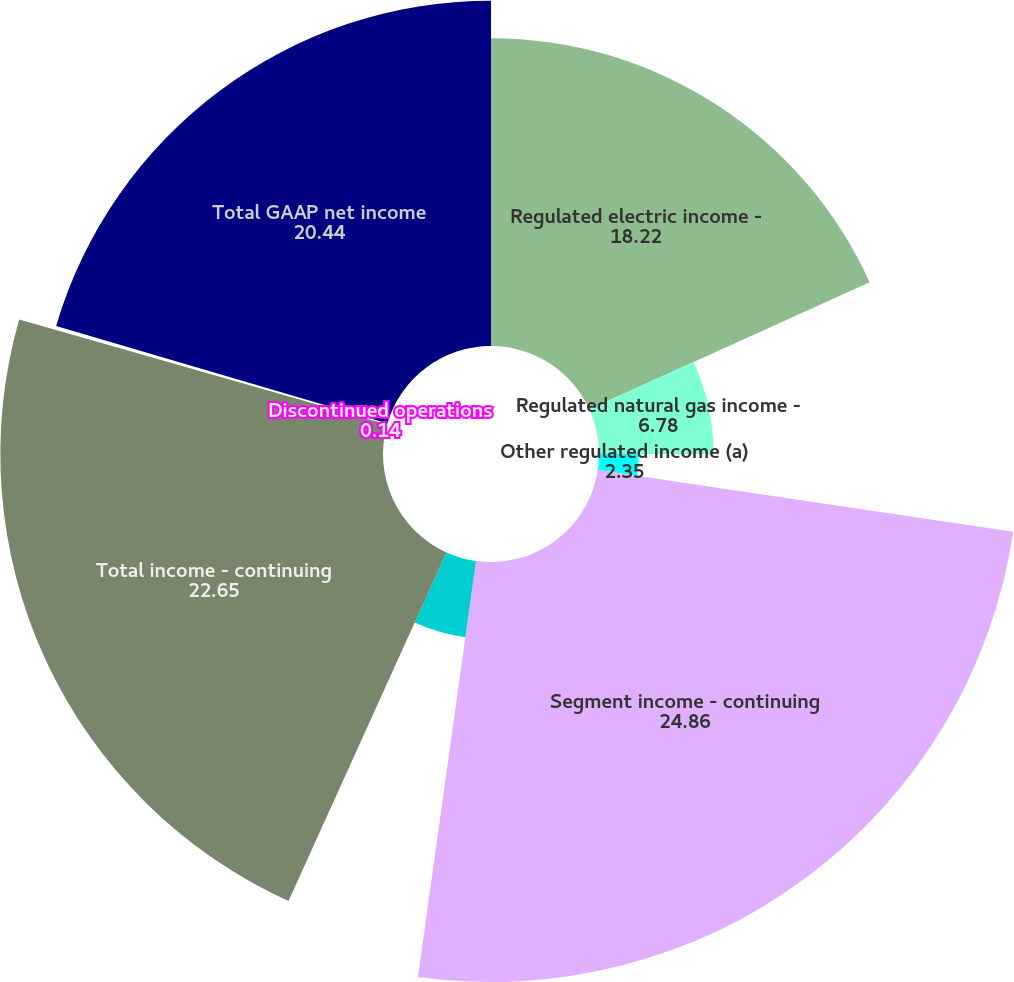<chart> <loc_0><loc_0><loc_500><loc_500><pie_chart><fcel>Regulated electric income -<fcel>Regulated natural gas income -<fcel>Other regulated income (a)<fcel>Segment income - continuing<fcel>Holding company and other<fcel>Total income - continuing<fcel>Discontinued operations<fcel>Total GAAP net income<nl><fcel>18.22%<fcel>6.78%<fcel>2.35%<fcel>24.86%<fcel>4.56%<fcel>22.65%<fcel>0.14%<fcel>20.44%<nl></chart> 